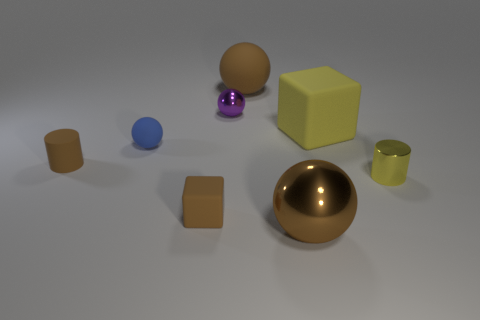Add 1 big green cylinders. How many objects exist? 9 Subtract all brown spheres. How many spheres are left? 2 Subtract 2 spheres. How many spheres are left? 2 Subtract all blocks. How many objects are left? 6 Subtract 0 gray spheres. How many objects are left? 8 Subtract all cyan balls. Subtract all brown cylinders. How many balls are left? 4 Subtract all blue spheres. How many gray cylinders are left? 0 Subtract all big brown rubber things. Subtract all purple spheres. How many objects are left? 6 Add 6 large brown objects. How many large brown objects are left? 8 Add 4 yellow shiny things. How many yellow shiny things exist? 5 